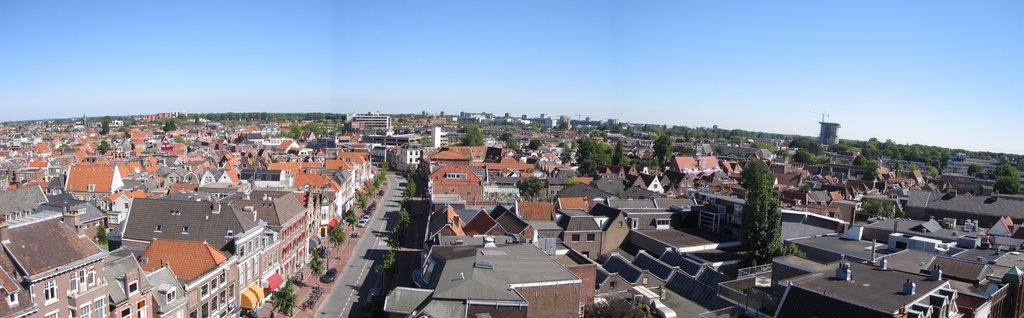What type of houses are visible in the image? There are houses with roof tiles in the image. What is located in the center of the image? There is a road in the center of the image. What can be seen between the houses in the image? There are trees between the houses in the image. What is visible at the top of the image? The sky is visible at the top of the image. Where is the grandmother sitting in the image? There is no grandmother present in the image. What type of lake can be seen in the image? There is no lake present in the image. 